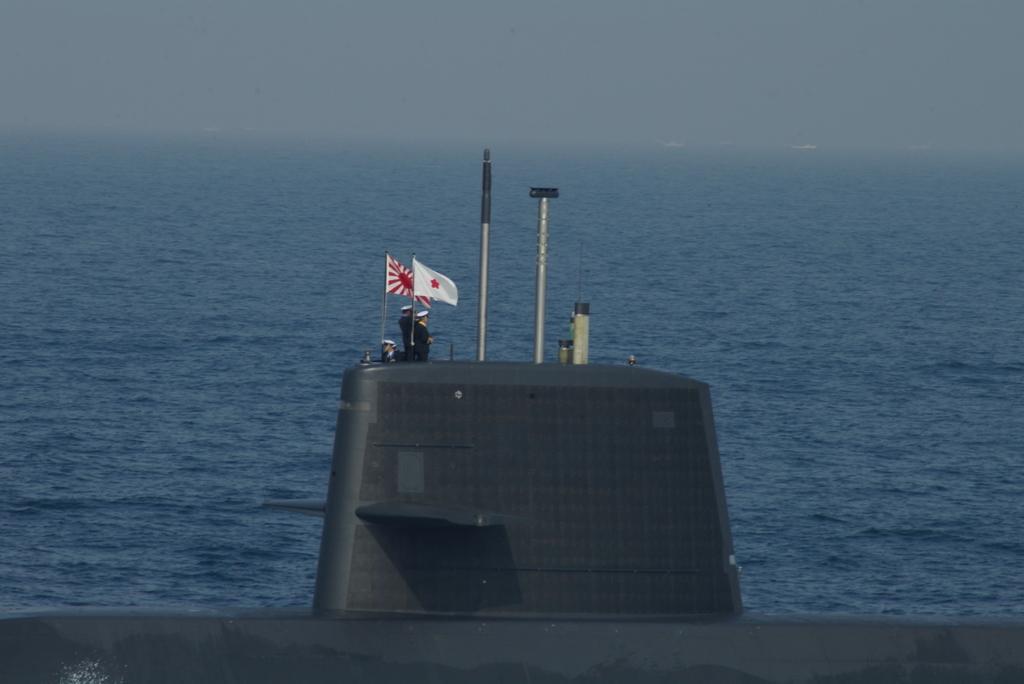Please provide a concise description of this image. This picture shows a submarine and we see few people on it and we see couple of flags and poles and we see few boats in the water. 